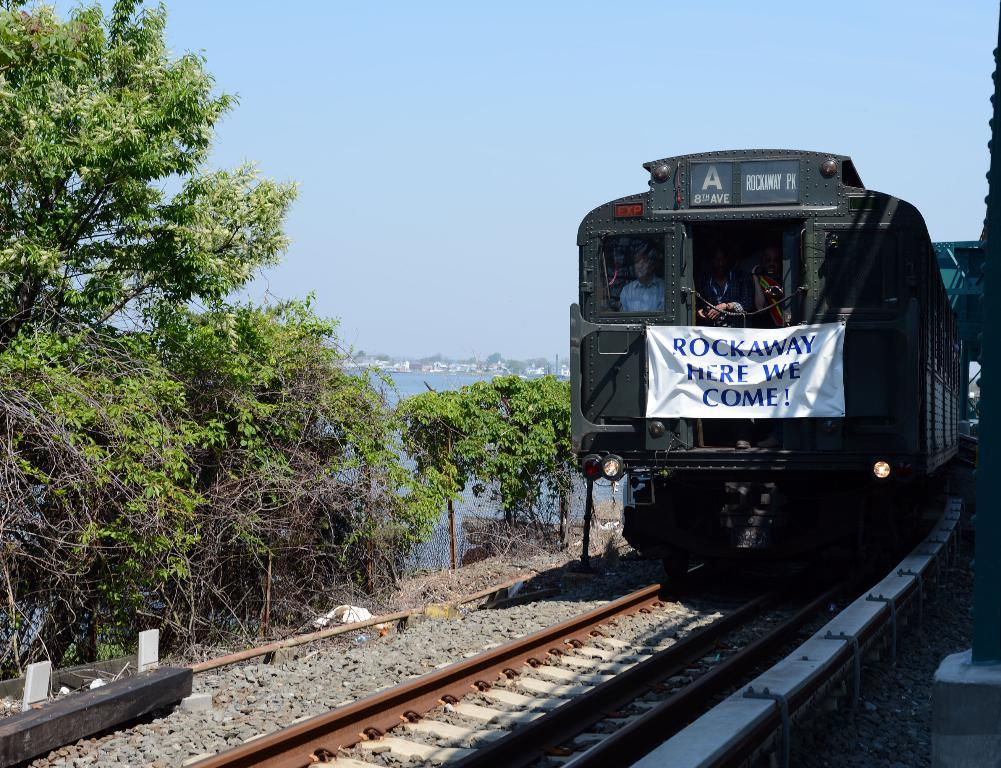<image>
Relay a brief, clear account of the picture shown. Train with a white sign which says "Rockaway Here we Come!". 